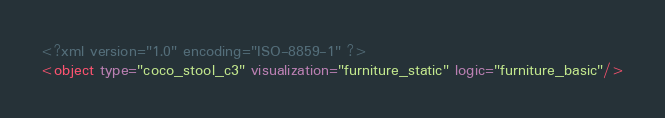Convert code to text. <code><loc_0><loc_0><loc_500><loc_500><_XML_><?xml version="1.0" encoding="ISO-8859-1" ?><object type="coco_stool_c3" visualization="furniture_static" logic="furniture_basic"/></code> 